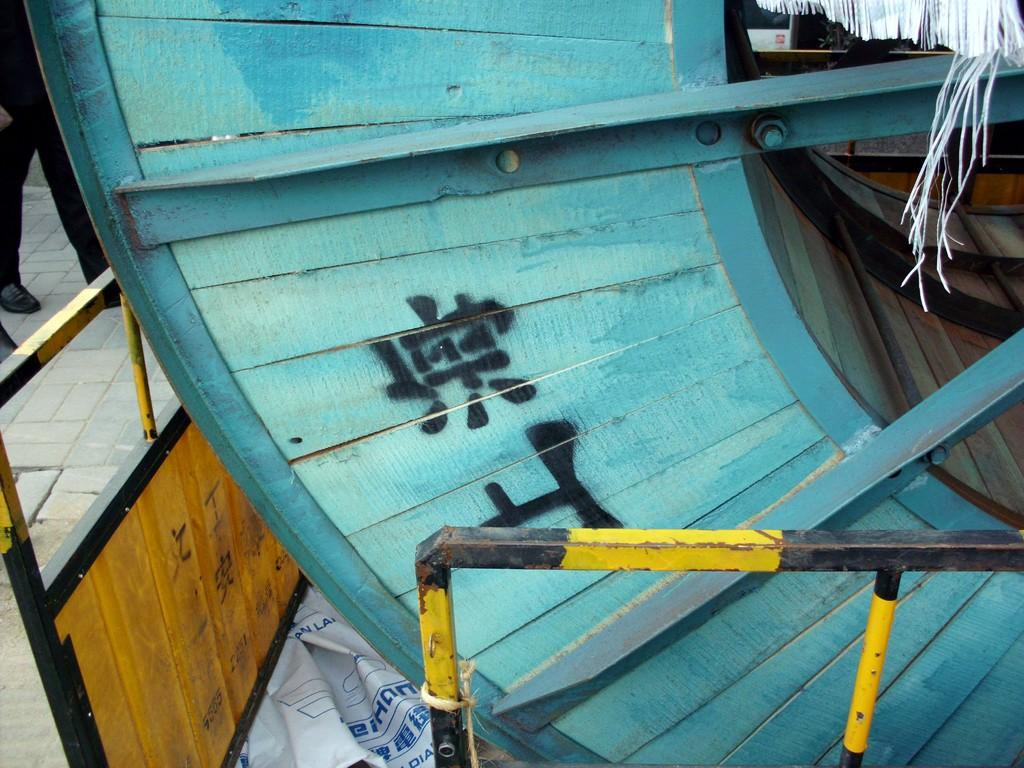What type of material is the wooden object made of in the image? The wooden object in the image is made of wood. What can be seen near the wooden object? There is a railing in the image. Are there any people present in the image? Yes, there are people in the image. What type of wax can be seen melting on the wooden object in the image? There is no wax present in the image, and therefore no wax can be seen melting on the wooden object. 